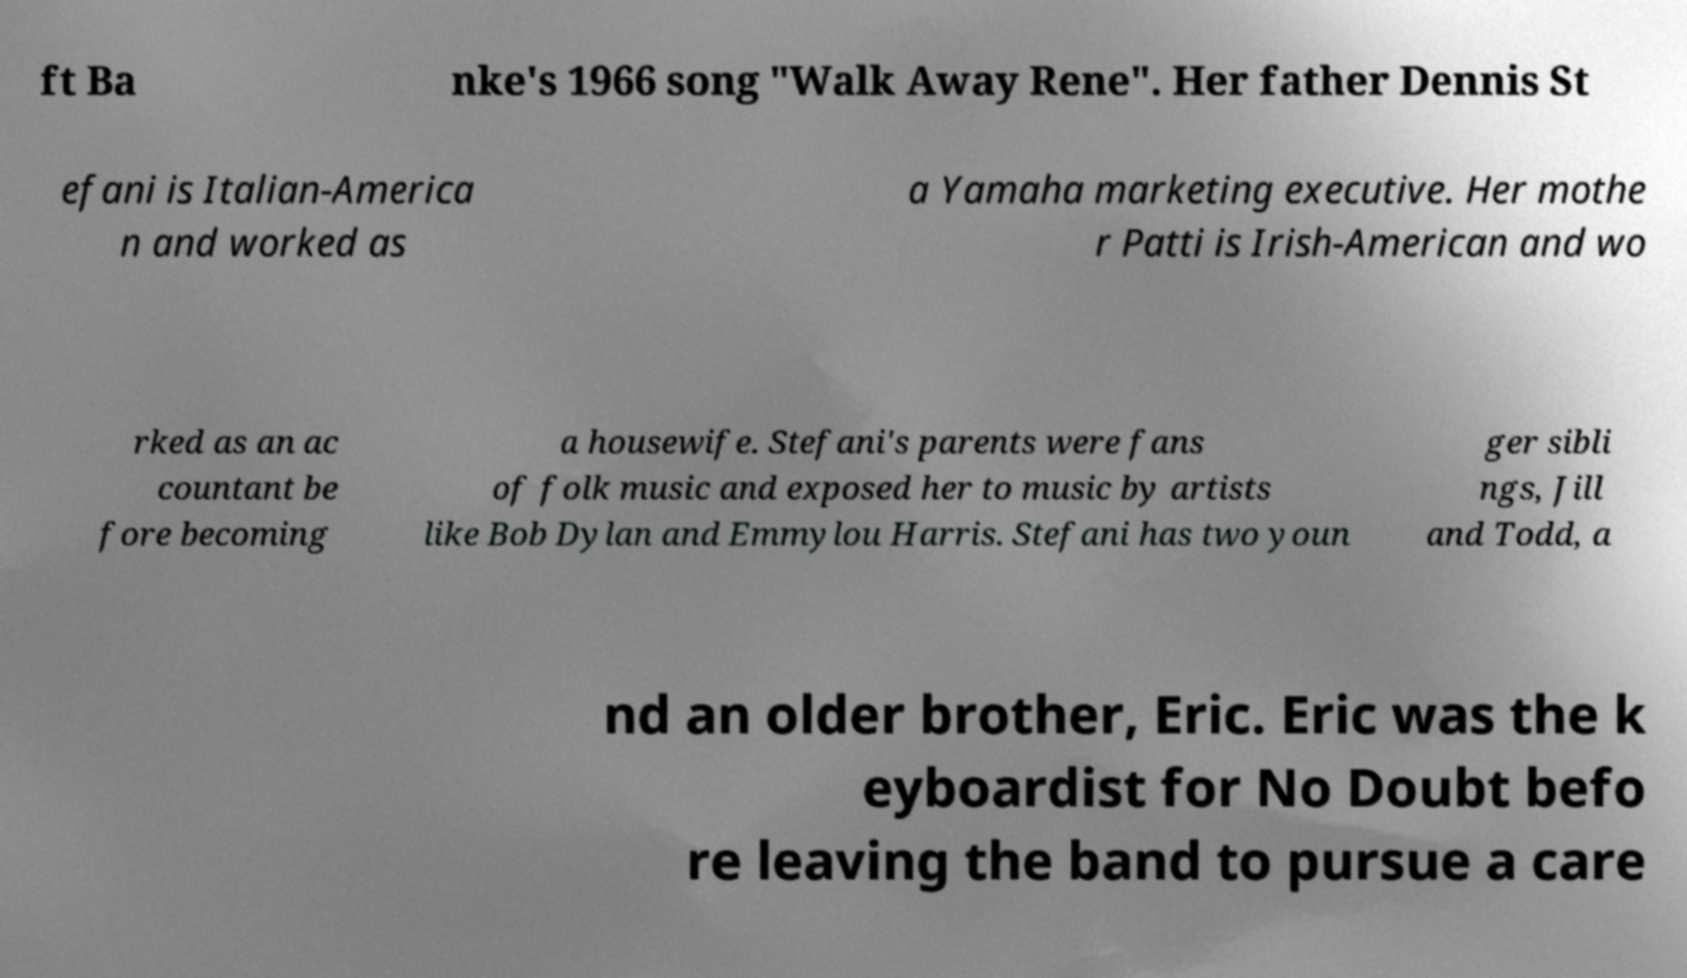Can you accurately transcribe the text from the provided image for me? ft Ba nke's 1966 song "Walk Away Rene". Her father Dennis St efani is Italian-America n and worked as a Yamaha marketing executive. Her mothe r Patti is Irish-American and wo rked as an ac countant be fore becoming a housewife. Stefani's parents were fans of folk music and exposed her to music by artists like Bob Dylan and Emmylou Harris. Stefani has two youn ger sibli ngs, Jill and Todd, a nd an older brother, Eric. Eric was the k eyboardist for No Doubt befo re leaving the band to pursue a care 